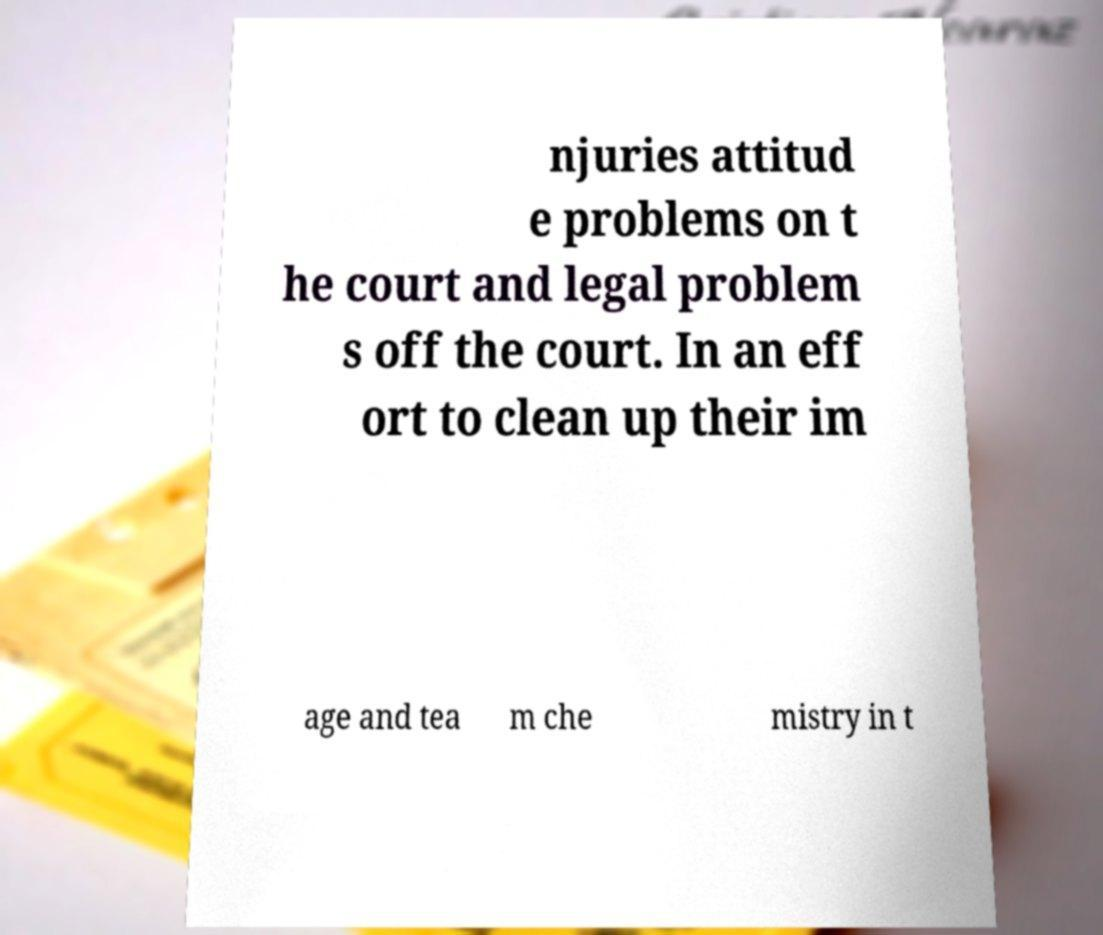Can you accurately transcribe the text from the provided image for me? njuries attitud e problems on t he court and legal problem s off the court. In an eff ort to clean up their im age and tea m che mistry in t 